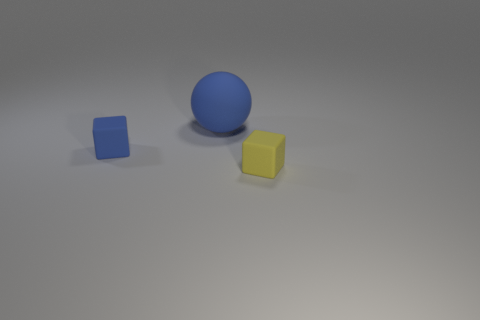What is the size of the rubber cube that is the same color as the large rubber thing?
Your answer should be very brief. Small. How many other objects are the same size as the yellow block?
Offer a very short reply. 1. There is a matte cube that is in front of the rubber block behind the small rubber block right of the rubber sphere; what is its color?
Give a very brief answer. Yellow. What number of other objects are there of the same shape as the big object?
Make the answer very short. 0. There is a blue object behind the blue rubber block; what shape is it?
Ensure brevity in your answer.  Sphere. There is a tiny rubber cube that is right of the large rubber ball; are there any small things behind it?
Your response must be concise. Yes. The thing that is both in front of the big blue sphere and left of the yellow rubber block is what color?
Give a very brief answer. Blue. Are there any tiny matte cubes right of the small rubber block that is behind the small rubber thing to the right of the blue cube?
Offer a terse response. Yes. Are any large yellow things visible?
Offer a very short reply. No. There is a large thing; is its color the same as the rubber cube on the left side of the big blue object?
Provide a succinct answer. Yes. 